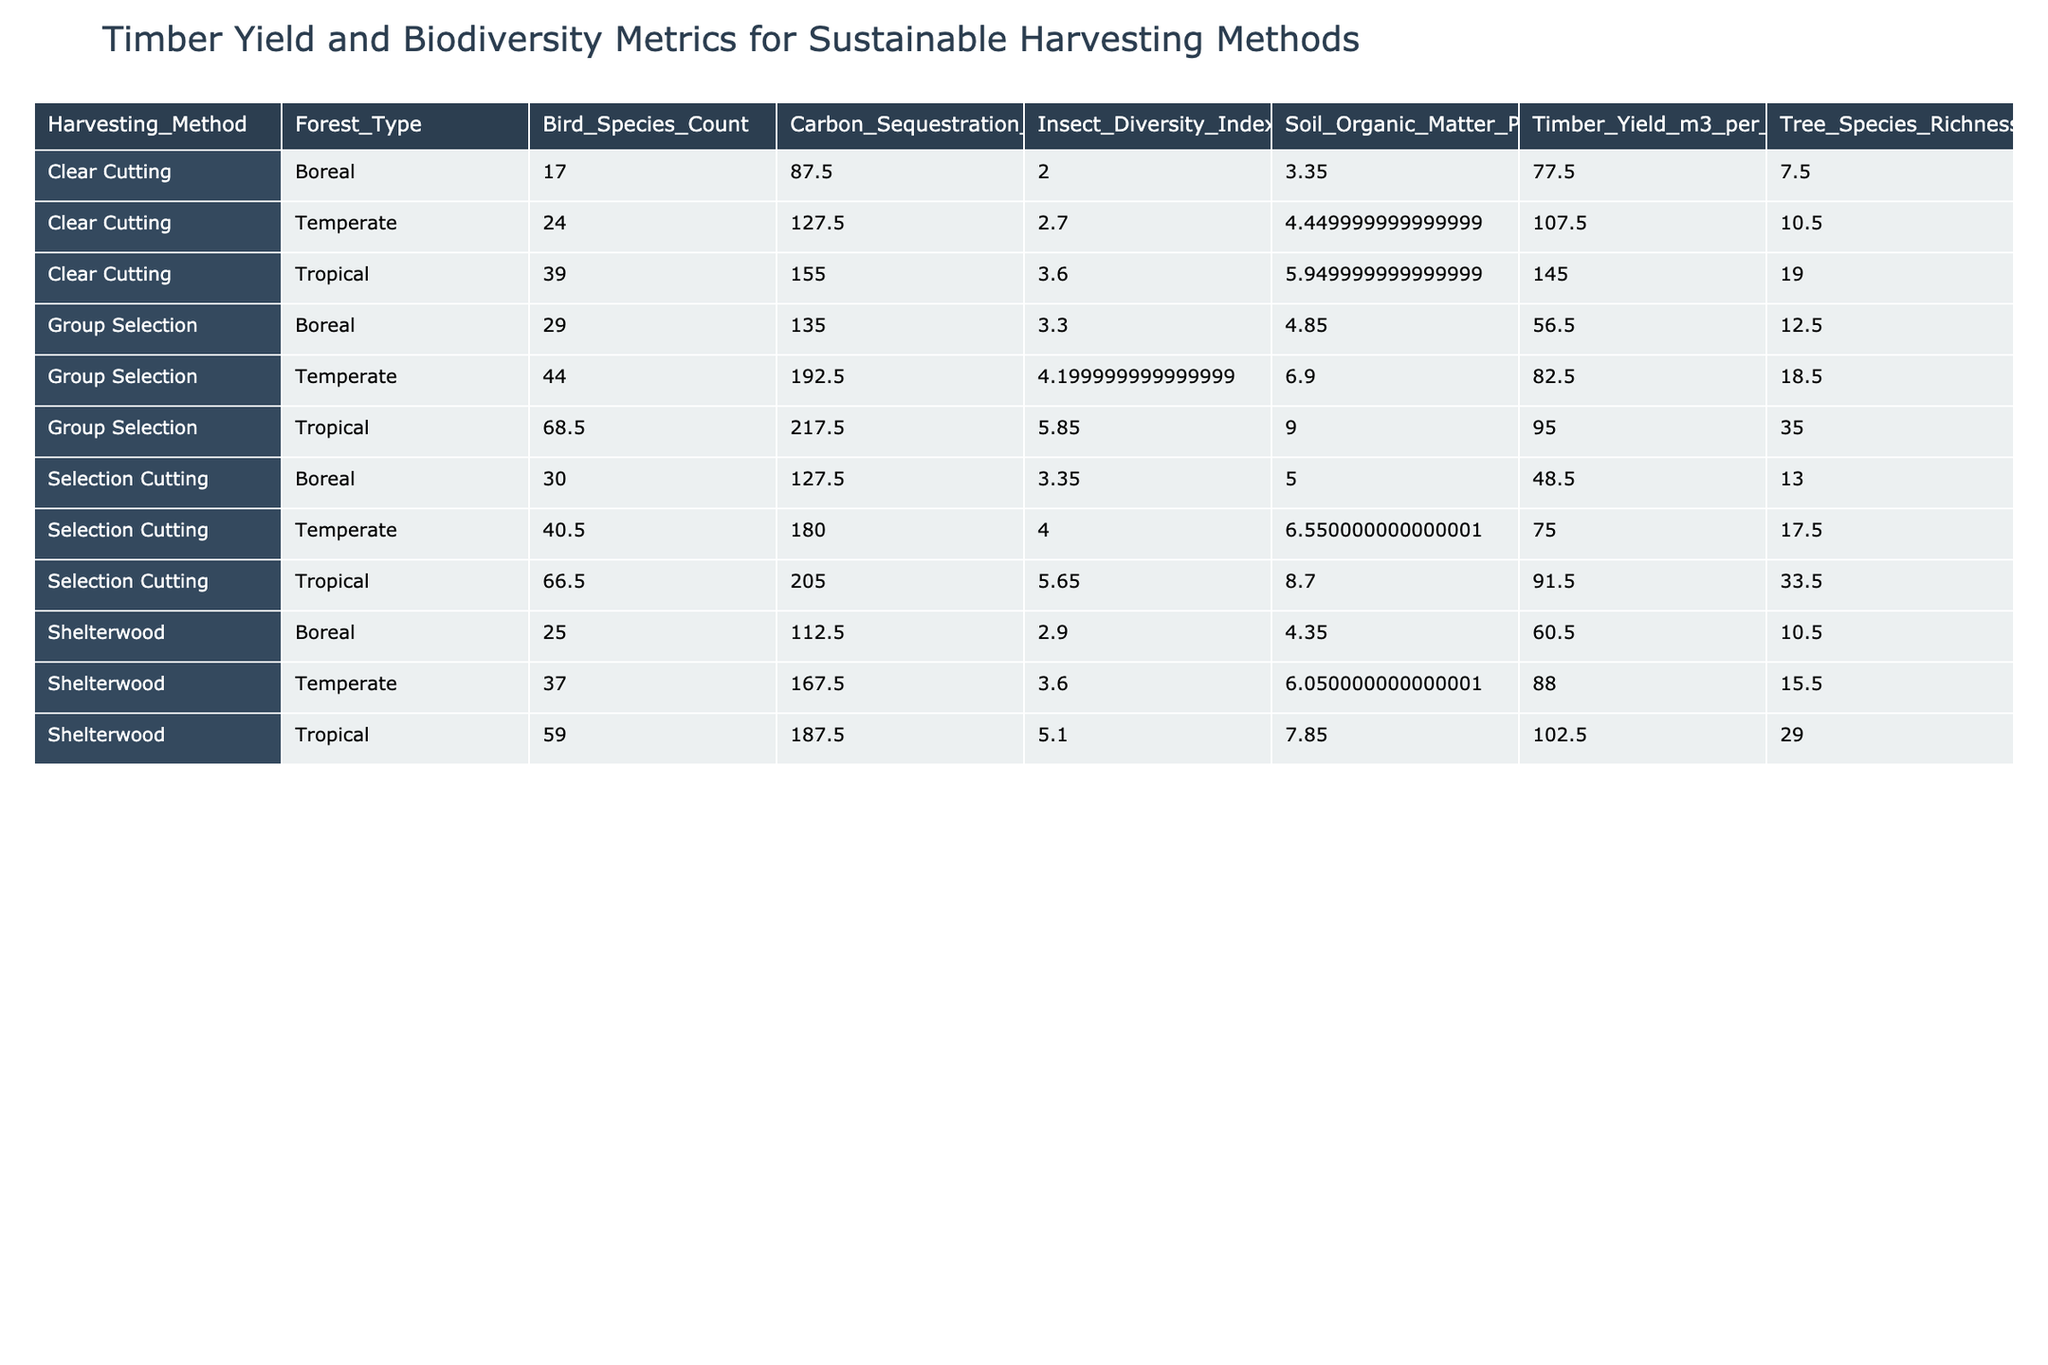What is the highest timber yield recorded and which harvesting method and forest type achieved it? The maximum timber yield in the table is 150 m3 per hectare, achieved through Clear Cutting in Tropical Malaysia.
Answer: 150 m3 per hectare, Clear Cutting, Tropical Malaysia What is the average number of tree species richness among all harvesting methods in the Tropical forest type? The total tree species richness for Tropical harvesting methods is (35 + 32 + 20 + 18 + 36 + 34) = 175 across 6 entries, which gives an average of 175/6 = 29.17.
Answer: 29.17 Did Selection Cutting or Clear Cutting have a higher average carbon sequestration across the given forest types? The average carbon sequestration for Selection Cutting is (120 + 135 + 185 + 175 + 210 + 200) = 1125 / 6 = 187.5 tons per hectare. For Clear Cutting, it is (90 + 85 + 130 + 125 + 160 + 150) = 740 / 6 = 123.33 tons per hectare. Since 187.5 is greater, Selection Cutting had a higher average.
Answer: Yes, Selection Cutting Which harvesting method consistently resulted in the highest bird species count among the listed forest types? From the table, Selection Cutting had the highest bird species counts in each entry for all forest types, namely (28, 32, 42, 39, 68, 65), summing to the maximum total.
Answer: Selection Cutting What is the average insect diversity index for the Group Selection method across identified forest types? The insect diversity indices for Group Selection are (30 + 28 + 45 + 43 + 70 + 67) = 283 for 6 entries, resulting in an average of 283/6 = 47.17.
Answer: 47.17 